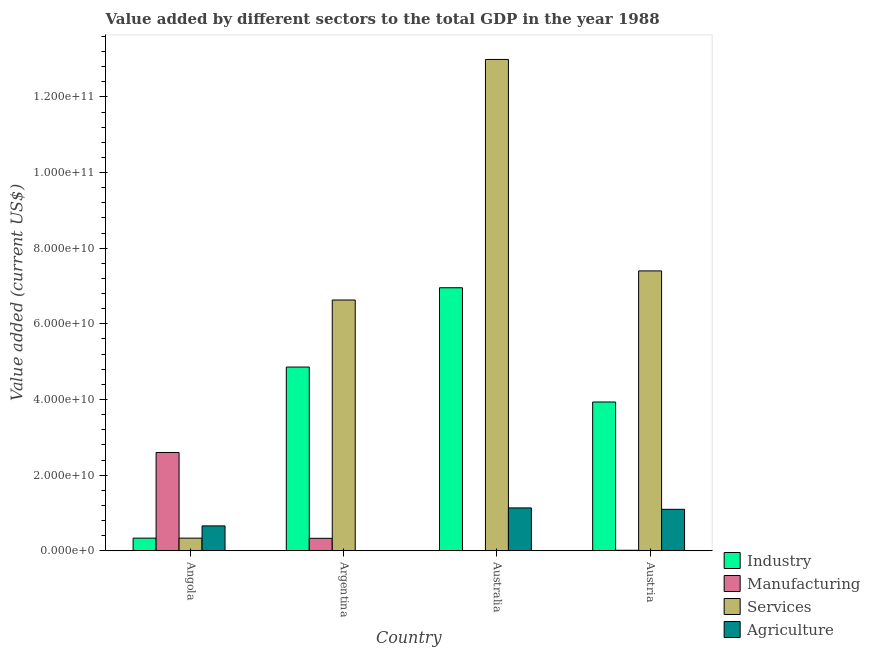How many different coloured bars are there?
Offer a very short reply. 4. How many groups of bars are there?
Provide a succinct answer. 4. Are the number of bars on each tick of the X-axis equal?
Offer a terse response. Yes. How many bars are there on the 3rd tick from the left?
Ensure brevity in your answer.  4. In how many cases, is the number of bars for a given country not equal to the number of legend labels?
Your answer should be compact. 0. What is the value added by agricultural sector in Australia?
Your response must be concise. 1.13e+1. Across all countries, what is the maximum value added by manufacturing sector?
Your response must be concise. 2.60e+1. Across all countries, what is the minimum value added by industrial sector?
Provide a succinct answer. 3.34e+09. In which country was the value added by industrial sector maximum?
Offer a terse response. Australia. In which country was the value added by services sector minimum?
Ensure brevity in your answer.  Angola. What is the total value added by manufacturing sector in the graph?
Your response must be concise. 2.95e+1. What is the difference between the value added by services sector in Argentina and that in Australia?
Your response must be concise. -6.36e+1. What is the difference between the value added by industrial sector in Angola and the value added by agricultural sector in Argentina?
Your answer should be compact. 3.33e+09. What is the average value added by manufacturing sector per country?
Provide a short and direct response. 7.37e+09. What is the difference between the value added by agricultural sector and value added by services sector in Argentina?
Give a very brief answer. -6.63e+1. In how many countries, is the value added by manufacturing sector greater than 92000000000 US$?
Give a very brief answer. 0. What is the ratio of the value added by industrial sector in Angola to that in Austria?
Provide a short and direct response. 0.08. Is the value added by industrial sector in Argentina less than that in Australia?
Provide a succinct answer. Yes. Is the difference between the value added by services sector in Angola and Australia greater than the difference between the value added by manufacturing sector in Angola and Australia?
Give a very brief answer. No. What is the difference between the highest and the second highest value added by agricultural sector?
Provide a short and direct response. 3.72e+08. What is the difference between the highest and the lowest value added by services sector?
Make the answer very short. 1.27e+11. What does the 3rd bar from the left in Argentina represents?
Offer a terse response. Services. What does the 3rd bar from the right in Argentina represents?
Your answer should be very brief. Manufacturing. How many bars are there?
Provide a succinct answer. 16. How many countries are there in the graph?
Keep it short and to the point. 4. Are the values on the major ticks of Y-axis written in scientific E-notation?
Make the answer very short. Yes. Does the graph contain any zero values?
Offer a terse response. No. Does the graph contain grids?
Provide a succinct answer. No. Where does the legend appear in the graph?
Your answer should be compact. Bottom right. What is the title of the graph?
Offer a very short reply. Value added by different sectors to the total GDP in the year 1988. What is the label or title of the X-axis?
Provide a short and direct response. Country. What is the label or title of the Y-axis?
Make the answer very short. Value added (current US$). What is the Value added (current US$) of Industry in Angola?
Provide a succinct answer. 3.34e+09. What is the Value added (current US$) of Manufacturing in Angola?
Provide a short and direct response. 2.60e+1. What is the Value added (current US$) of Services in Angola?
Offer a very short reply. 3.34e+09. What is the Value added (current US$) of Agriculture in Angola?
Ensure brevity in your answer.  6.58e+09. What is the Value added (current US$) of Industry in Argentina?
Offer a terse response. 4.86e+1. What is the Value added (current US$) of Manufacturing in Argentina?
Offer a terse response. 3.30e+09. What is the Value added (current US$) in Services in Argentina?
Give a very brief answer. 6.63e+1. What is the Value added (current US$) in Agriculture in Argentina?
Offer a terse response. 1.19e+07. What is the Value added (current US$) in Industry in Australia?
Ensure brevity in your answer.  6.95e+1. What is the Value added (current US$) of Manufacturing in Australia?
Make the answer very short. 4.92e+07. What is the Value added (current US$) in Services in Australia?
Provide a short and direct response. 1.30e+11. What is the Value added (current US$) in Agriculture in Australia?
Ensure brevity in your answer.  1.13e+1. What is the Value added (current US$) of Industry in Austria?
Your response must be concise. 3.93e+1. What is the Value added (current US$) in Manufacturing in Austria?
Your answer should be compact. 1.32e+08. What is the Value added (current US$) in Services in Austria?
Provide a short and direct response. 7.40e+1. What is the Value added (current US$) of Agriculture in Austria?
Ensure brevity in your answer.  1.10e+1. Across all countries, what is the maximum Value added (current US$) in Industry?
Offer a very short reply. 6.95e+1. Across all countries, what is the maximum Value added (current US$) in Manufacturing?
Your answer should be compact. 2.60e+1. Across all countries, what is the maximum Value added (current US$) of Services?
Keep it short and to the point. 1.30e+11. Across all countries, what is the maximum Value added (current US$) of Agriculture?
Make the answer very short. 1.13e+1. Across all countries, what is the minimum Value added (current US$) in Industry?
Keep it short and to the point. 3.34e+09. Across all countries, what is the minimum Value added (current US$) in Manufacturing?
Your answer should be very brief. 4.92e+07. Across all countries, what is the minimum Value added (current US$) of Services?
Give a very brief answer. 3.34e+09. Across all countries, what is the minimum Value added (current US$) of Agriculture?
Give a very brief answer. 1.19e+07. What is the total Value added (current US$) of Industry in the graph?
Provide a succinct answer. 1.61e+11. What is the total Value added (current US$) in Manufacturing in the graph?
Provide a short and direct response. 2.95e+1. What is the total Value added (current US$) of Services in the graph?
Ensure brevity in your answer.  2.74e+11. What is the total Value added (current US$) of Agriculture in the graph?
Provide a succinct answer. 2.89e+1. What is the difference between the Value added (current US$) of Industry in Angola and that in Argentina?
Provide a short and direct response. -4.52e+1. What is the difference between the Value added (current US$) of Manufacturing in Angola and that in Argentina?
Offer a terse response. 2.27e+1. What is the difference between the Value added (current US$) in Services in Angola and that in Argentina?
Provide a short and direct response. -6.30e+1. What is the difference between the Value added (current US$) of Agriculture in Angola and that in Argentina?
Ensure brevity in your answer.  6.56e+09. What is the difference between the Value added (current US$) of Industry in Angola and that in Australia?
Provide a short and direct response. -6.62e+1. What is the difference between the Value added (current US$) of Manufacturing in Angola and that in Australia?
Make the answer very short. 2.59e+1. What is the difference between the Value added (current US$) in Services in Angola and that in Australia?
Your answer should be compact. -1.27e+11. What is the difference between the Value added (current US$) in Agriculture in Angola and that in Australia?
Make the answer very short. -4.75e+09. What is the difference between the Value added (current US$) of Industry in Angola and that in Austria?
Your answer should be very brief. -3.60e+1. What is the difference between the Value added (current US$) in Manufacturing in Angola and that in Austria?
Your answer should be compact. 2.59e+1. What is the difference between the Value added (current US$) of Services in Angola and that in Austria?
Your response must be concise. -7.07e+1. What is the difference between the Value added (current US$) of Agriculture in Angola and that in Austria?
Provide a succinct answer. -4.38e+09. What is the difference between the Value added (current US$) in Industry in Argentina and that in Australia?
Ensure brevity in your answer.  -2.10e+1. What is the difference between the Value added (current US$) in Manufacturing in Argentina and that in Australia?
Keep it short and to the point. 3.25e+09. What is the difference between the Value added (current US$) of Services in Argentina and that in Australia?
Your answer should be compact. -6.36e+1. What is the difference between the Value added (current US$) of Agriculture in Argentina and that in Australia?
Offer a very short reply. -1.13e+1. What is the difference between the Value added (current US$) of Industry in Argentina and that in Austria?
Your answer should be compact. 9.23e+09. What is the difference between the Value added (current US$) in Manufacturing in Argentina and that in Austria?
Make the answer very short. 3.17e+09. What is the difference between the Value added (current US$) in Services in Argentina and that in Austria?
Your answer should be very brief. -7.70e+09. What is the difference between the Value added (current US$) in Agriculture in Argentina and that in Austria?
Make the answer very short. -1.09e+1. What is the difference between the Value added (current US$) in Industry in Australia and that in Austria?
Your answer should be compact. 3.02e+1. What is the difference between the Value added (current US$) in Manufacturing in Australia and that in Austria?
Provide a succinct answer. -8.26e+07. What is the difference between the Value added (current US$) of Services in Australia and that in Austria?
Your response must be concise. 5.59e+1. What is the difference between the Value added (current US$) of Agriculture in Australia and that in Austria?
Ensure brevity in your answer.  3.72e+08. What is the difference between the Value added (current US$) in Industry in Angola and the Value added (current US$) in Manufacturing in Argentina?
Keep it short and to the point. 4.44e+07. What is the difference between the Value added (current US$) of Industry in Angola and the Value added (current US$) of Services in Argentina?
Keep it short and to the point. -6.30e+1. What is the difference between the Value added (current US$) of Industry in Angola and the Value added (current US$) of Agriculture in Argentina?
Provide a short and direct response. 3.33e+09. What is the difference between the Value added (current US$) of Manufacturing in Angola and the Value added (current US$) of Services in Argentina?
Your answer should be very brief. -4.03e+1. What is the difference between the Value added (current US$) of Manufacturing in Angola and the Value added (current US$) of Agriculture in Argentina?
Your answer should be compact. 2.60e+1. What is the difference between the Value added (current US$) in Services in Angola and the Value added (current US$) in Agriculture in Argentina?
Make the answer very short. 3.33e+09. What is the difference between the Value added (current US$) in Industry in Angola and the Value added (current US$) in Manufacturing in Australia?
Provide a short and direct response. 3.29e+09. What is the difference between the Value added (current US$) of Industry in Angola and the Value added (current US$) of Services in Australia?
Make the answer very short. -1.27e+11. What is the difference between the Value added (current US$) of Industry in Angola and the Value added (current US$) of Agriculture in Australia?
Make the answer very short. -7.99e+09. What is the difference between the Value added (current US$) in Manufacturing in Angola and the Value added (current US$) in Services in Australia?
Provide a short and direct response. -1.04e+11. What is the difference between the Value added (current US$) of Manufacturing in Angola and the Value added (current US$) of Agriculture in Australia?
Provide a short and direct response. 1.47e+1. What is the difference between the Value added (current US$) in Services in Angola and the Value added (current US$) in Agriculture in Australia?
Your response must be concise. -7.99e+09. What is the difference between the Value added (current US$) of Industry in Angola and the Value added (current US$) of Manufacturing in Austria?
Offer a terse response. 3.21e+09. What is the difference between the Value added (current US$) in Industry in Angola and the Value added (current US$) in Services in Austria?
Provide a short and direct response. -7.07e+1. What is the difference between the Value added (current US$) of Industry in Angola and the Value added (current US$) of Agriculture in Austria?
Offer a terse response. -7.62e+09. What is the difference between the Value added (current US$) in Manufacturing in Angola and the Value added (current US$) in Services in Austria?
Make the answer very short. -4.80e+1. What is the difference between the Value added (current US$) in Manufacturing in Angola and the Value added (current US$) in Agriculture in Austria?
Keep it short and to the point. 1.50e+1. What is the difference between the Value added (current US$) of Services in Angola and the Value added (current US$) of Agriculture in Austria?
Provide a succinct answer. -7.62e+09. What is the difference between the Value added (current US$) of Industry in Argentina and the Value added (current US$) of Manufacturing in Australia?
Provide a short and direct response. 4.85e+1. What is the difference between the Value added (current US$) in Industry in Argentina and the Value added (current US$) in Services in Australia?
Offer a terse response. -8.13e+1. What is the difference between the Value added (current US$) of Industry in Argentina and the Value added (current US$) of Agriculture in Australia?
Ensure brevity in your answer.  3.72e+1. What is the difference between the Value added (current US$) in Manufacturing in Argentina and the Value added (current US$) in Services in Australia?
Ensure brevity in your answer.  -1.27e+11. What is the difference between the Value added (current US$) of Manufacturing in Argentina and the Value added (current US$) of Agriculture in Australia?
Offer a terse response. -8.03e+09. What is the difference between the Value added (current US$) of Services in Argentina and the Value added (current US$) of Agriculture in Australia?
Offer a very short reply. 5.50e+1. What is the difference between the Value added (current US$) in Industry in Argentina and the Value added (current US$) in Manufacturing in Austria?
Provide a succinct answer. 4.84e+1. What is the difference between the Value added (current US$) of Industry in Argentina and the Value added (current US$) of Services in Austria?
Provide a short and direct response. -2.54e+1. What is the difference between the Value added (current US$) of Industry in Argentina and the Value added (current US$) of Agriculture in Austria?
Give a very brief answer. 3.76e+1. What is the difference between the Value added (current US$) of Manufacturing in Argentina and the Value added (current US$) of Services in Austria?
Ensure brevity in your answer.  -7.07e+1. What is the difference between the Value added (current US$) in Manufacturing in Argentina and the Value added (current US$) in Agriculture in Austria?
Make the answer very short. -7.66e+09. What is the difference between the Value added (current US$) in Services in Argentina and the Value added (current US$) in Agriculture in Austria?
Give a very brief answer. 5.53e+1. What is the difference between the Value added (current US$) of Industry in Australia and the Value added (current US$) of Manufacturing in Austria?
Your response must be concise. 6.94e+1. What is the difference between the Value added (current US$) in Industry in Australia and the Value added (current US$) in Services in Austria?
Make the answer very short. -4.45e+09. What is the difference between the Value added (current US$) of Industry in Australia and the Value added (current US$) of Agriculture in Austria?
Offer a terse response. 5.86e+1. What is the difference between the Value added (current US$) in Manufacturing in Australia and the Value added (current US$) in Services in Austria?
Your answer should be compact. -7.39e+1. What is the difference between the Value added (current US$) of Manufacturing in Australia and the Value added (current US$) of Agriculture in Austria?
Offer a terse response. -1.09e+1. What is the difference between the Value added (current US$) in Services in Australia and the Value added (current US$) in Agriculture in Austria?
Ensure brevity in your answer.  1.19e+11. What is the average Value added (current US$) of Industry per country?
Your answer should be very brief. 4.02e+1. What is the average Value added (current US$) in Manufacturing per country?
Offer a terse response. 7.37e+09. What is the average Value added (current US$) of Services per country?
Your answer should be compact. 6.84e+1. What is the average Value added (current US$) of Agriculture per country?
Give a very brief answer. 7.22e+09. What is the difference between the Value added (current US$) of Industry and Value added (current US$) of Manufacturing in Angola?
Your response must be concise. -2.26e+1. What is the difference between the Value added (current US$) of Industry and Value added (current US$) of Agriculture in Angola?
Your answer should be compact. -3.23e+09. What is the difference between the Value added (current US$) of Manufacturing and Value added (current US$) of Services in Angola?
Make the answer very short. 2.26e+1. What is the difference between the Value added (current US$) of Manufacturing and Value added (current US$) of Agriculture in Angola?
Keep it short and to the point. 1.94e+1. What is the difference between the Value added (current US$) in Services and Value added (current US$) in Agriculture in Angola?
Keep it short and to the point. -3.23e+09. What is the difference between the Value added (current US$) in Industry and Value added (current US$) in Manufacturing in Argentina?
Offer a terse response. 4.53e+1. What is the difference between the Value added (current US$) in Industry and Value added (current US$) in Services in Argentina?
Your answer should be compact. -1.77e+1. What is the difference between the Value added (current US$) of Industry and Value added (current US$) of Agriculture in Argentina?
Provide a short and direct response. 4.86e+1. What is the difference between the Value added (current US$) in Manufacturing and Value added (current US$) in Services in Argentina?
Ensure brevity in your answer.  -6.30e+1. What is the difference between the Value added (current US$) of Manufacturing and Value added (current US$) of Agriculture in Argentina?
Give a very brief answer. 3.29e+09. What is the difference between the Value added (current US$) of Services and Value added (current US$) of Agriculture in Argentina?
Your answer should be compact. 6.63e+1. What is the difference between the Value added (current US$) in Industry and Value added (current US$) in Manufacturing in Australia?
Provide a short and direct response. 6.95e+1. What is the difference between the Value added (current US$) in Industry and Value added (current US$) in Services in Australia?
Offer a very short reply. -6.04e+1. What is the difference between the Value added (current US$) in Industry and Value added (current US$) in Agriculture in Australia?
Your response must be concise. 5.82e+1. What is the difference between the Value added (current US$) of Manufacturing and Value added (current US$) of Services in Australia?
Offer a terse response. -1.30e+11. What is the difference between the Value added (current US$) in Manufacturing and Value added (current US$) in Agriculture in Australia?
Offer a terse response. -1.13e+1. What is the difference between the Value added (current US$) in Services and Value added (current US$) in Agriculture in Australia?
Provide a short and direct response. 1.19e+11. What is the difference between the Value added (current US$) of Industry and Value added (current US$) of Manufacturing in Austria?
Keep it short and to the point. 3.92e+1. What is the difference between the Value added (current US$) in Industry and Value added (current US$) in Services in Austria?
Your answer should be compact. -3.47e+1. What is the difference between the Value added (current US$) in Industry and Value added (current US$) in Agriculture in Austria?
Offer a terse response. 2.84e+1. What is the difference between the Value added (current US$) in Manufacturing and Value added (current US$) in Services in Austria?
Provide a short and direct response. -7.39e+1. What is the difference between the Value added (current US$) of Manufacturing and Value added (current US$) of Agriculture in Austria?
Ensure brevity in your answer.  -1.08e+1. What is the difference between the Value added (current US$) in Services and Value added (current US$) in Agriculture in Austria?
Give a very brief answer. 6.30e+1. What is the ratio of the Value added (current US$) of Industry in Angola to that in Argentina?
Provide a succinct answer. 0.07. What is the ratio of the Value added (current US$) in Manufacturing in Angola to that in Argentina?
Give a very brief answer. 7.88. What is the ratio of the Value added (current US$) of Services in Angola to that in Argentina?
Your response must be concise. 0.05. What is the ratio of the Value added (current US$) in Agriculture in Angola to that in Argentina?
Your answer should be very brief. 553.18. What is the ratio of the Value added (current US$) in Industry in Angola to that in Australia?
Make the answer very short. 0.05. What is the ratio of the Value added (current US$) in Manufacturing in Angola to that in Australia?
Provide a short and direct response. 528.8. What is the ratio of the Value added (current US$) in Services in Angola to that in Australia?
Offer a terse response. 0.03. What is the ratio of the Value added (current US$) in Agriculture in Angola to that in Australia?
Keep it short and to the point. 0.58. What is the ratio of the Value added (current US$) in Industry in Angola to that in Austria?
Your response must be concise. 0.09. What is the ratio of the Value added (current US$) of Manufacturing in Angola to that in Austria?
Keep it short and to the point. 197.29. What is the ratio of the Value added (current US$) in Services in Angola to that in Austria?
Keep it short and to the point. 0.05. What is the ratio of the Value added (current US$) in Agriculture in Angola to that in Austria?
Your answer should be compact. 0.6. What is the ratio of the Value added (current US$) of Industry in Argentina to that in Australia?
Give a very brief answer. 0.7. What is the ratio of the Value added (current US$) in Manufacturing in Argentina to that in Australia?
Offer a terse response. 67.1. What is the ratio of the Value added (current US$) of Services in Argentina to that in Australia?
Your response must be concise. 0.51. What is the ratio of the Value added (current US$) of Industry in Argentina to that in Austria?
Provide a succinct answer. 1.23. What is the ratio of the Value added (current US$) in Manufacturing in Argentina to that in Austria?
Keep it short and to the point. 25.03. What is the ratio of the Value added (current US$) in Services in Argentina to that in Austria?
Your answer should be compact. 0.9. What is the ratio of the Value added (current US$) of Agriculture in Argentina to that in Austria?
Keep it short and to the point. 0. What is the ratio of the Value added (current US$) of Industry in Australia to that in Austria?
Your answer should be compact. 1.77. What is the ratio of the Value added (current US$) of Manufacturing in Australia to that in Austria?
Keep it short and to the point. 0.37. What is the ratio of the Value added (current US$) of Services in Australia to that in Austria?
Make the answer very short. 1.76. What is the ratio of the Value added (current US$) in Agriculture in Australia to that in Austria?
Keep it short and to the point. 1.03. What is the difference between the highest and the second highest Value added (current US$) in Industry?
Provide a short and direct response. 2.10e+1. What is the difference between the highest and the second highest Value added (current US$) of Manufacturing?
Provide a short and direct response. 2.27e+1. What is the difference between the highest and the second highest Value added (current US$) of Services?
Provide a short and direct response. 5.59e+1. What is the difference between the highest and the second highest Value added (current US$) in Agriculture?
Your answer should be compact. 3.72e+08. What is the difference between the highest and the lowest Value added (current US$) of Industry?
Your answer should be very brief. 6.62e+1. What is the difference between the highest and the lowest Value added (current US$) in Manufacturing?
Make the answer very short. 2.59e+1. What is the difference between the highest and the lowest Value added (current US$) of Services?
Offer a very short reply. 1.27e+11. What is the difference between the highest and the lowest Value added (current US$) in Agriculture?
Ensure brevity in your answer.  1.13e+1. 